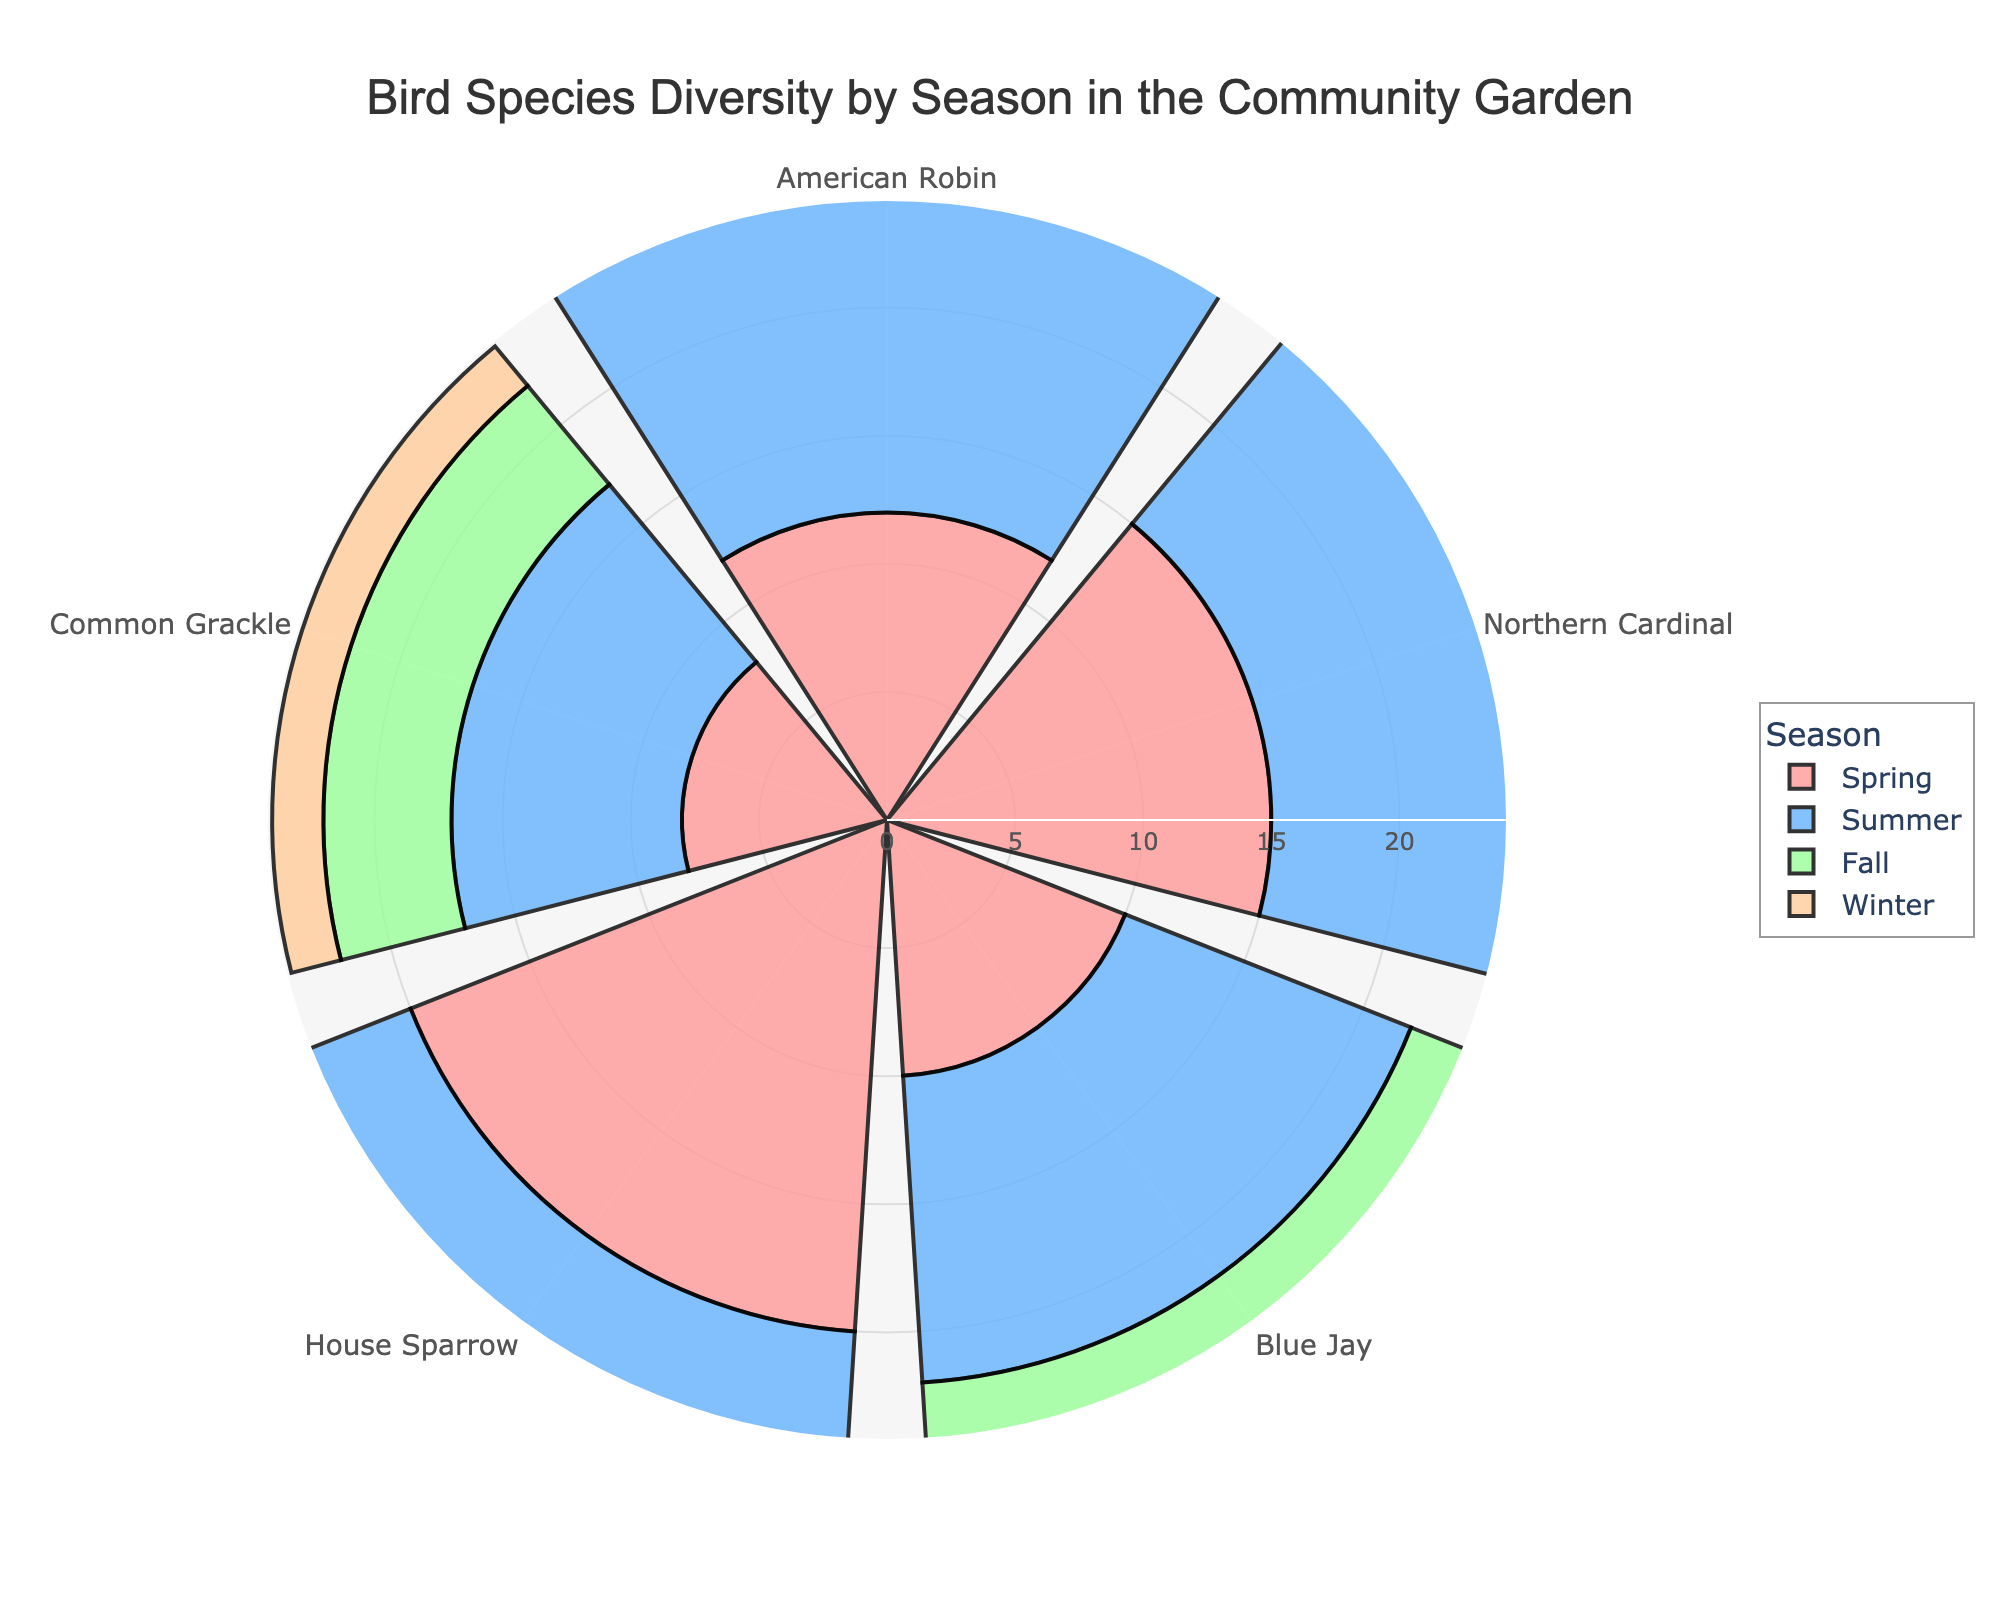What's the title of the figure? The title of the figure is shown at the top and is "Bird Species Diversity by Season in the Community Garden".
Answer: Bird Species Diversity by Season in the Community Garden What season shows the highest count for the House Sparrow? By examining the data points for each season, the House Sparrow has the highest count in the Summer with 22.
Answer: Summer How many bird species were observed in the Winter? Observing each season's bird species, there are 5 different bird species in the Winter season as represented in the chart: American Robin, Northern Cardinal, Blue Jay, House Sparrow, and Common Grackle.
Answer: 5 In which season is the American Robin least observed? The counts of American Robin across seasons are 12 (Spring), 14 (Summer), 9 (Fall), and 3 (Winter). The least observation is in Winter as indicated by the smallest radial bar.
Answer: Winter Compare the count of Common Grackle in Winter and Summer. Based on the radial lengths in the chart for Common Grackle, Winter has a count of 2, and Summer has a count of 9. Thus, Common Grackle is observed more in Summer.
Answer: Summer What is the total count of Blue Jays across all seasons? The counts for Blue Jay are 10 (Spring), 12 (Summer), 7 (Fall), and 4 (Winter). Summing these values: 10 + 12 + 7 + 4 = 33.
Answer: 33 Which bird species has the consistent count across Spring, Summer, Fall, and Winter? By analyzing each bird species' counts across seasons, Northern Cardinal has consistently high counts though it varies. For a species with non-zero presence in each season, it can be the House Sparrow: 20 (Spring), 22 (Summer), 15 (Fall), and 10 (Winter). The variability makes this tricky, but House Sparrow presence is pronounced each season.
Answer: House Sparrow During which season is bird species diversity (number of different species observed) highest? Checking the number of distinct species across seasons: all seasons (Spring, Summer, Fall, Winter) have 5 species, so diversity is constant.
Answer: All Seasons Compare the total bird count in Spring to that in Fall. The total counts for species in Spring sum to 65 (12 + 15 + 10 + 20 + 8) and in Fall to 48 (9 + 12 + 7 + 15 + 5). Hence, Spring has a higher total count compared to Fall.
Answer: Spring What is the smallest count observed for any bird species in any season? By observing each bar's shortest length, Common Grackle has the smallest count of 2 in Winter.
Answer: 2 